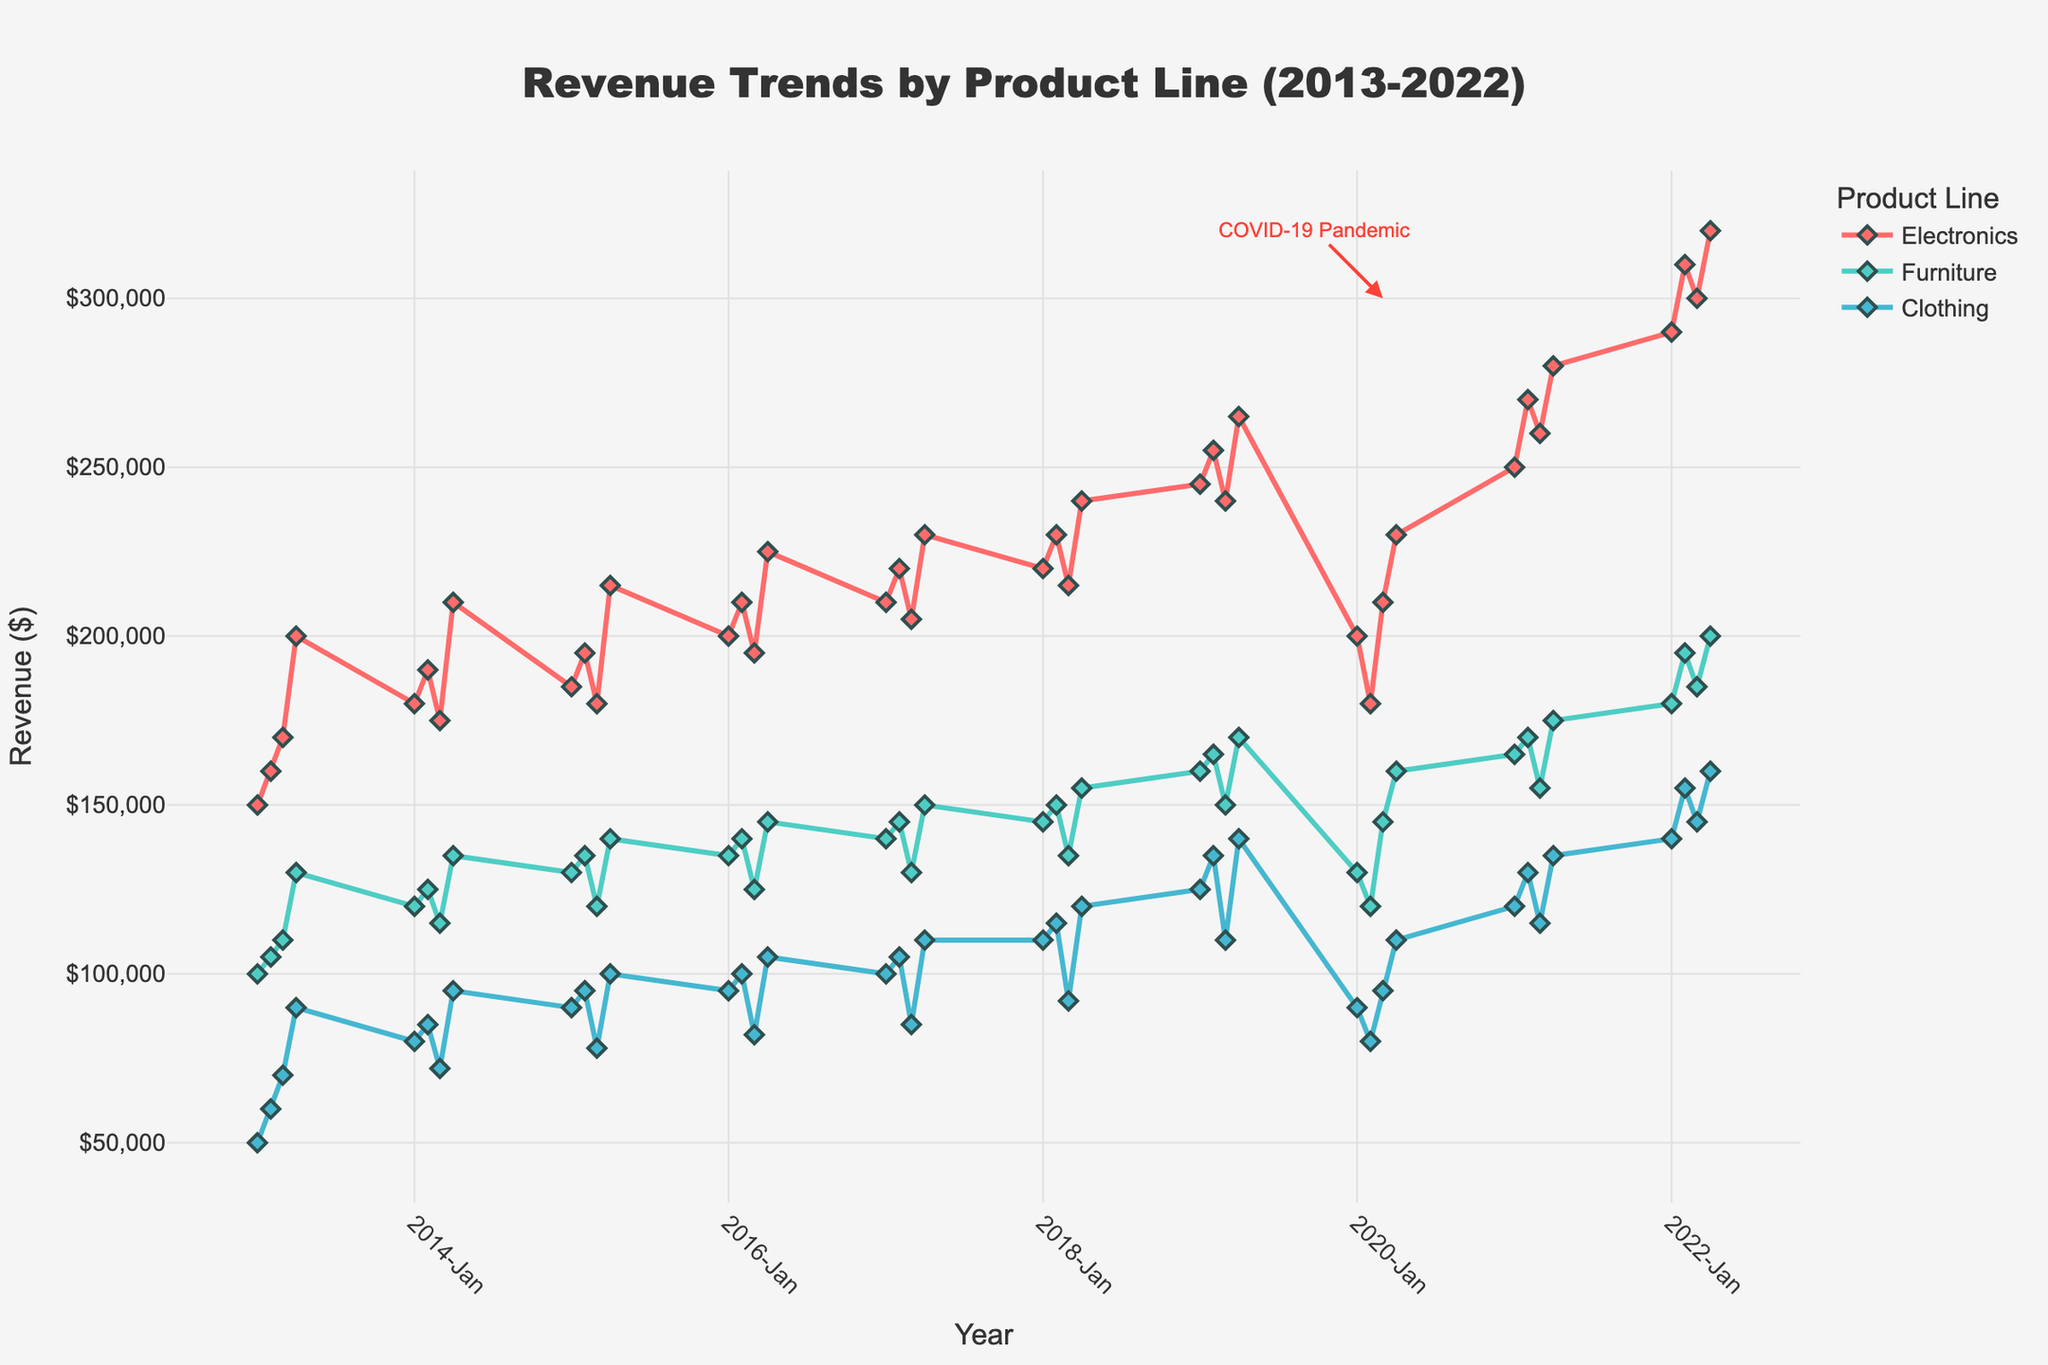What's the title of the figure? The title of the figure is displayed at the top of the plot, centered and highlighted. It provides a clear description of what the plot represents.
Answer: Revenue Trends by Product Line (2013-2022) What occurs around 2020 for each product line? Looking at the annotations and the time series data points around 2020, especially focusing on the annotation "COVID-19 Pandemic," one can observe the drop or change in trends for each product line. The Electronics and Clothing lines see a sharp decline in revenue around early 2020, then a recovery.
Answer: Decline in Electronics and Clothing, slight drop then recovery in Furniture Which product line has shown the most significant increase in revenue over the 10-year period? By comparing the end points of each colored line, we can see which product line has the highest difference from the beginning to the end of the time period. The Clothing line shows a considerable increase from around $50k to around $160k.
Answer: Clothing How does Electronics revenue in Q1 2019 compare to Q1 2020? Locate the data points for Q1 2019 and Q1 2020 for Electronics on the time axis. The revenue in Q1 2019 is about $245,000 while Q1 2020 shows a sharp decrease to around $200,000.
Answer: Q1 2019 is higher by $45,000 What is the general trend for Furniture revenue over the past 10 years? Observing the Furniture revenue line from 2013 to 2022, one can identify the general upward slope, indicating an increase. The detailed ups and downs indicate some fluctuations but an overall increase from around $100k to $200k.
Answer: Increasing trend Which quarter consistently shows the highest revenues for Electronics? By observing the markers and their positions for each year, one can identify that Q4 consistently shows the highest revenue values for Electronics. This is seen by the peaks in Q4 markers throughout the timeline.
Answer: Q4 How did the revenues of all product lines compare in Q1 2022? Locate Q1 2022 on the time axis and compare the revenue values for each product line. You notice that Electronics had the highest, followed by Furniture, and then Clothing. Electronics is about $290k, Furniture about $180k, and Clothing around $140k.
Answer: Electronics > Furniture > Clothing Considering seasonal variations, which product line shows the largest seasonal fluctuations? By observing the amplitude of ups and downs in the plotted lines for each product line, Electronics shows the largest seasonal fluctuations, especially notable around Q4 each year compared to the other lines.
Answer: Electronics 